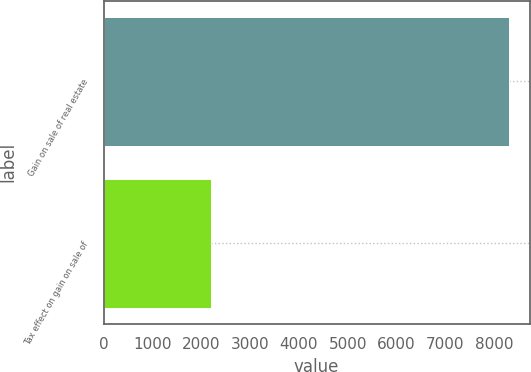Convert chart to OTSL. <chart><loc_0><loc_0><loc_500><loc_500><bar_chart><fcel>Gain on sale of real estate<fcel>Tax effect on gain on sale of<nl><fcel>8307<fcel>2205<nl></chart> 